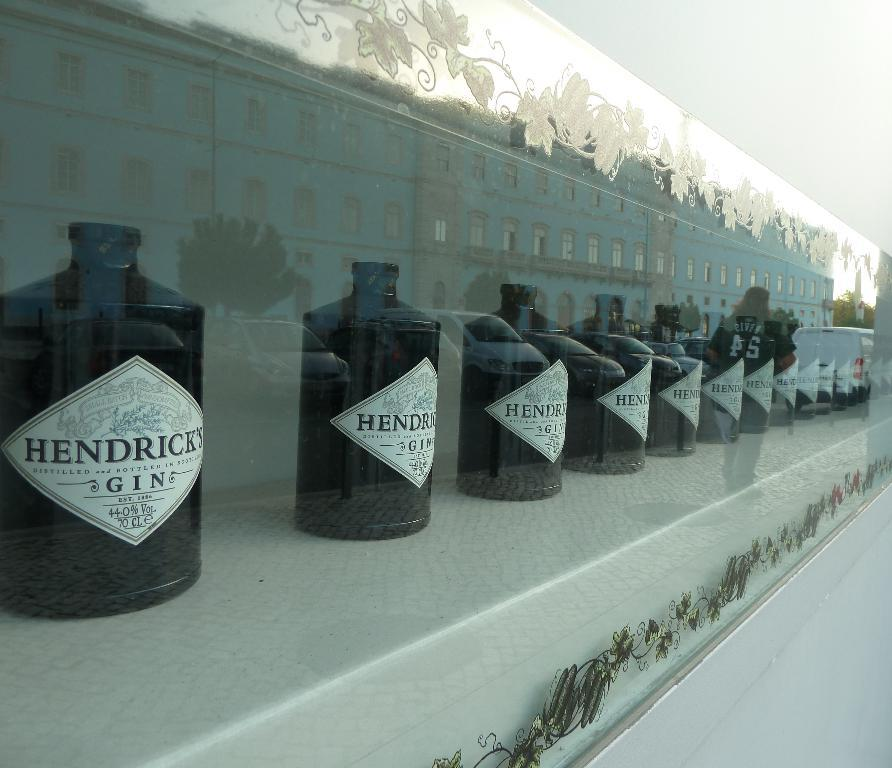What is the main subject of the image? The main subject of the image is many alcohol bottles. How are the bottles displayed in the image? The bottles are kept behind a glass. What can be seen reflected on the glass? The images of cars, trees, and buildings are reflected on the glass. What type of toy can be seen in the arm of the person in the image? There is no person or toy present in the image; it features alcohol bottles behind a glass with reflected images. 